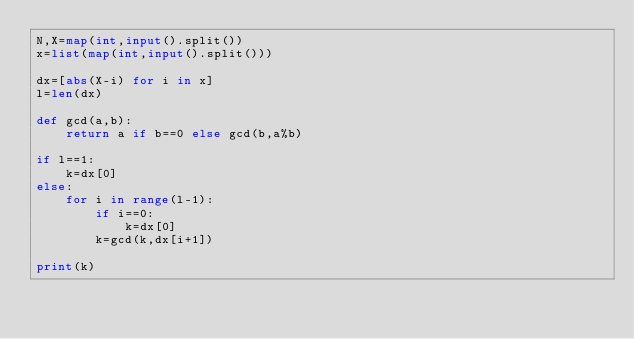Convert code to text. <code><loc_0><loc_0><loc_500><loc_500><_Python_>N,X=map(int,input().split())
x=list(map(int,input().split()))

dx=[abs(X-i) for i in x]
l=len(dx)

def gcd(a,b):
    return a if b==0 else gcd(b,a%b)

if l==1:
    k=dx[0]
else:
    for i in range(l-1):
        if i==0:
            k=dx[0]
        k=gcd(k,dx[i+1])

print(k)
</code> 